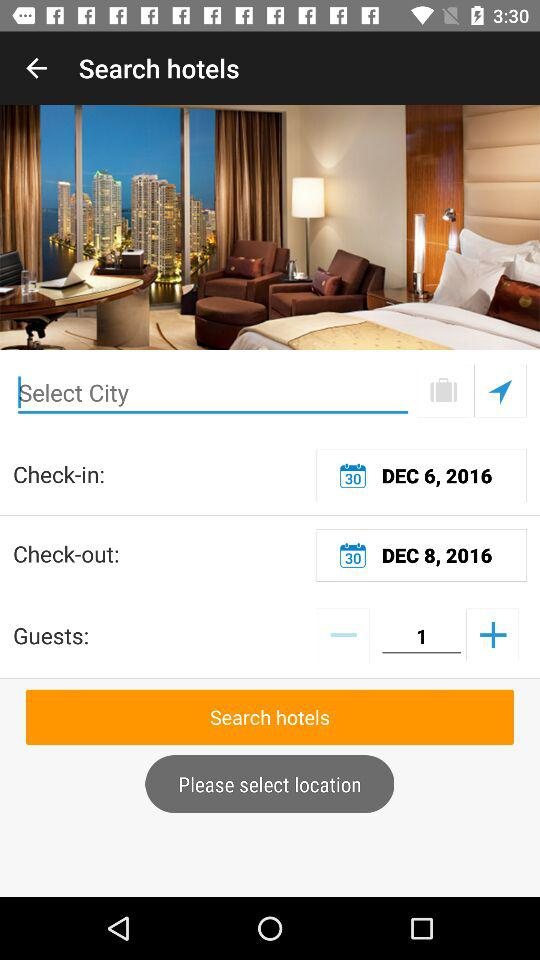What is the check-in date? The check-in date is December 6, 2016. 